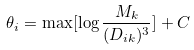Convert formula to latex. <formula><loc_0><loc_0><loc_500><loc_500>\theta _ { i } = \max [ \log \frac { M _ { k } } { ( D _ { i k } ) ^ { 3 } } ] + C</formula> 